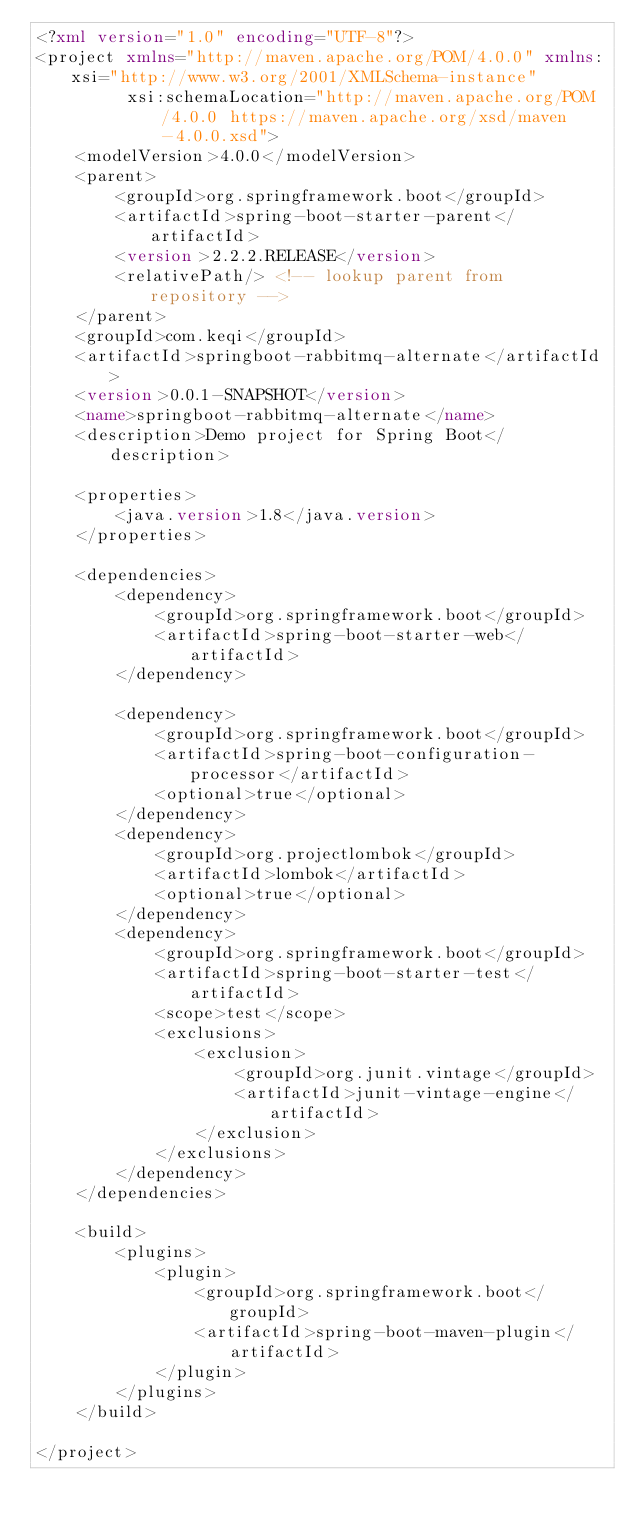Convert code to text. <code><loc_0><loc_0><loc_500><loc_500><_XML_><?xml version="1.0" encoding="UTF-8"?>
<project xmlns="http://maven.apache.org/POM/4.0.0" xmlns:xsi="http://www.w3.org/2001/XMLSchema-instance"
         xsi:schemaLocation="http://maven.apache.org/POM/4.0.0 https://maven.apache.org/xsd/maven-4.0.0.xsd">
    <modelVersion>4.0.0</modelVersion>
    <parent>
        <groupId>org.springframework.boot</groupId>
        <artifactId>spring-boot-starter-parent</artifactId>
        <version>2.2.2.RELEASE</version>
        <relativePath/> <!-- lookup parent from repository -->
    </parent>
    <groupId>com.keqi</groupId>
    <artifactId>springboot-rabbitmq-alternate</artifactId>
    <version>0.0.1-SNAPSHOT</version>
    <name>springboot-rabbitmq-alternate</name>
    <description>Demo project for Spring Boot</description>

    <properties>
        <java.version>1.8</java.version>
    </properties>

    <dependencies>
        <dependency>
            <groupId>org.springframework.boot</groupId>
            <artifactId>spring-boot-starter-web</artifactId>
        </dependency>

        <dependency>
            <groupId>org.springframework.boot</groupId>
            <artifactId>spring-boot-configuration-processor</artifactId>
            <optional>true</optional>
        </dependency>
        <dependency>
            <groupId>org.projectlombok</groupId>
            <artifactId>lombok</artifactId>
            <optional>true</optional>
        </dependency>
        <dependency>
            <groupId>org.springframework.boot</groupId>
            <artifactId>spring-boot-starter-test</artifactId>
            <scope>test</scope>
            <exclusions>
                <exclusion>
                    <groupId>org.junit.vintage</groupId>
                    <artifactId>junit-vintage-engine</artifactId>
                </exclusion>
            </exclusions>
        </dependency>
    </dependencies>

    <build>
        <plugins>
            <plugin>
                <groupId>org.springframework.boot</groupId>
                <artifactId>spring-boot-maven-plugin</artifactId>
            </plugin>
        </plugins>
    </build>

</project>
</code> 